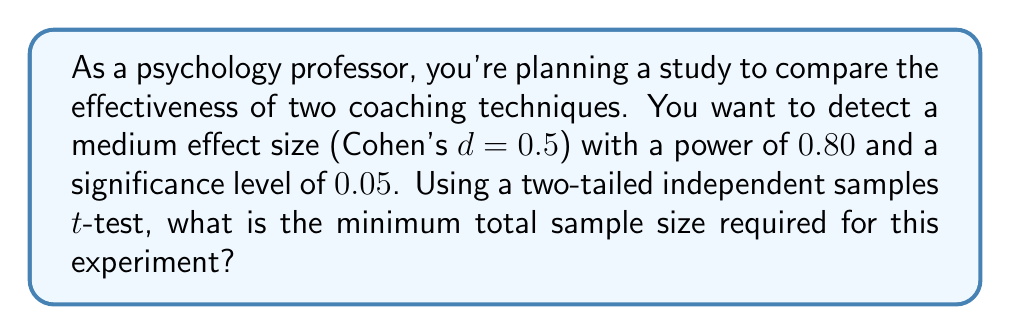Give your solution to this math problem. To determine the sample size using power analysis, we'll follow these steps:

1. Identify the parameters:
   - Effect size (d) = 0.5 (medium effect)
   - Power (1 - β) = 0.80
   - Significance level (α) = 0.05
   - Test type: Two-tailed independent samples t-test

2. Use the power analysis formula for two independent samples:

   $$n = \frac{2(z_{1-\alpha/2} + z_{1-\beta})^2}{d^2}$$

   Where:
   - $n$ is the sample size per group
   - $z_{1-\alpha/2}$ is the critical value for α/2
   - $z_{1-\beta}$ is the critical value for the desired power

3. Find the critical values:
   - For α = 0.05 (two-tailed), $z_{1-\alpha/2} = 1.96$
   - For power = 0.80, $z_{1-\beta} = 0.84$

4. Plug the values into the formula:

   $$n = \frac{2(1.96 + 0.84)^2}{0.5^2} = \frac{2(2.80)^2}{0.25} = \frac{15.68}{0.25} = 62.72$$

5. Round up to the nearest whole number:
   $n = 63$ per group

6. Calculate the total sample size:
   Total sample size = $2n = 2 * 63 = 126$

Therefore, the minimum total sample size required for this experiment is 126 participants, with 63 in each coaching technique group.
Answer: 126 